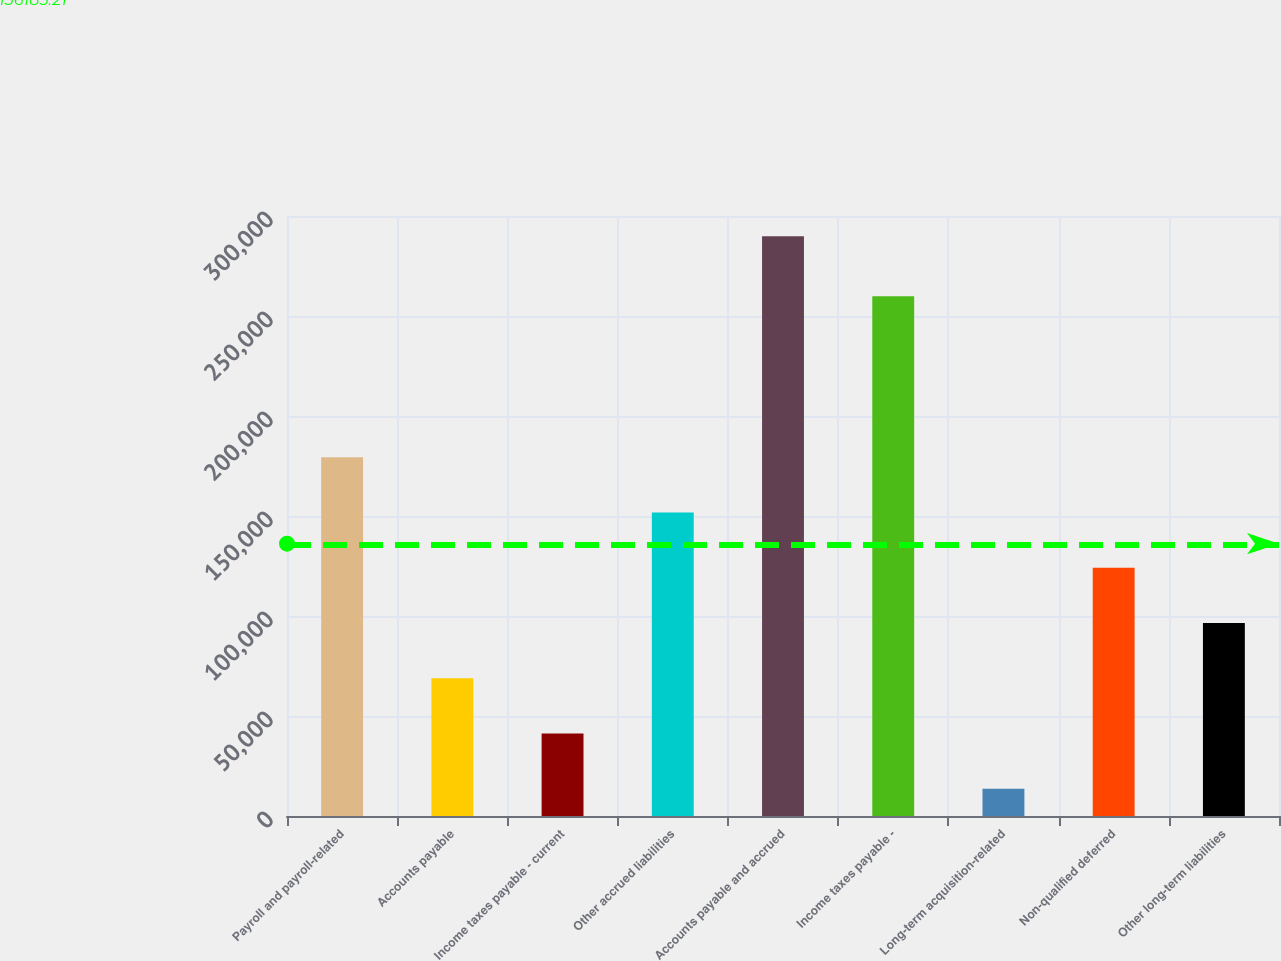Convert chart to OTSL. <chart><loc_0><loc_0><loc_500><loc_500><bar_chart><fcel>Payroll and payroll-related<fcel>Accounts payable<fcel>Income taxes payable - current<fcel>Other accrued liabilities<fcel>Accounts payable and accrued<fcel>Income taxes payable -<fcel>Long-term acquisition-related<fcel>Non-qualified deferred<fcel>Other long-term liabilities<nl><fcel>179434<fcel>68934.8<fcel>41309.9<fcel>151810<fcel>289934<fcel>259815<fcel>13685<fcel>124185<fcel>96559.7<nl></chart> 